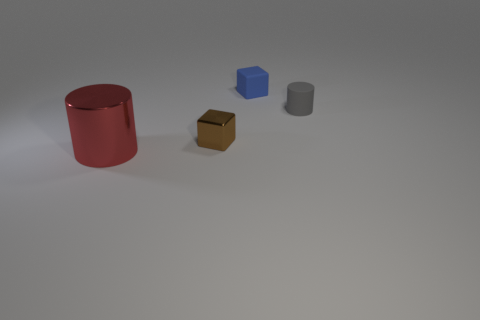There is a small object that is behind the gray object; what shape is it?
Offer a very short reply. Cube. What is the shape of the thing in front of the small shiny thing in front of the block to the right of the small brown shiny block?
Ensure brevity in your answer.  Cylinder. Does the tiny brown object that is on the left side of the blue block have the same shape as the large shiny thing left of the blue thing?
Provide a succinct answer. No. What number of small things are both in front of the small blue object and on the right side of the small metallic object?
Your answer should be compact. 1. There is a thing that is to the left of the gray object and on the right side of the tiny brown metal block; what is it made of?
Ensure brevity in your answer.  Rubber. There is a blue rubber object that is the same shape as the small metallic object; what size is it?
Offer a terse response. Small. What is the shape of the thing that is both on the left side of the gray cylinder and right of the small shiny block?
Offer a terse response. Cube. Do the gray rubber object and the block that is on the right side of the tiny brown metallic cube have the same size?
Keep it short and to the point. Yes. What is the color of the other tiny object that is the same shape as the red metal thing?
Provide a short and direct response. Gray. Do the cylinder left of the gray cylinder and the shiny thing on the right side of the large metal cylinder have the same size?
Provide a succinct answer. No. 